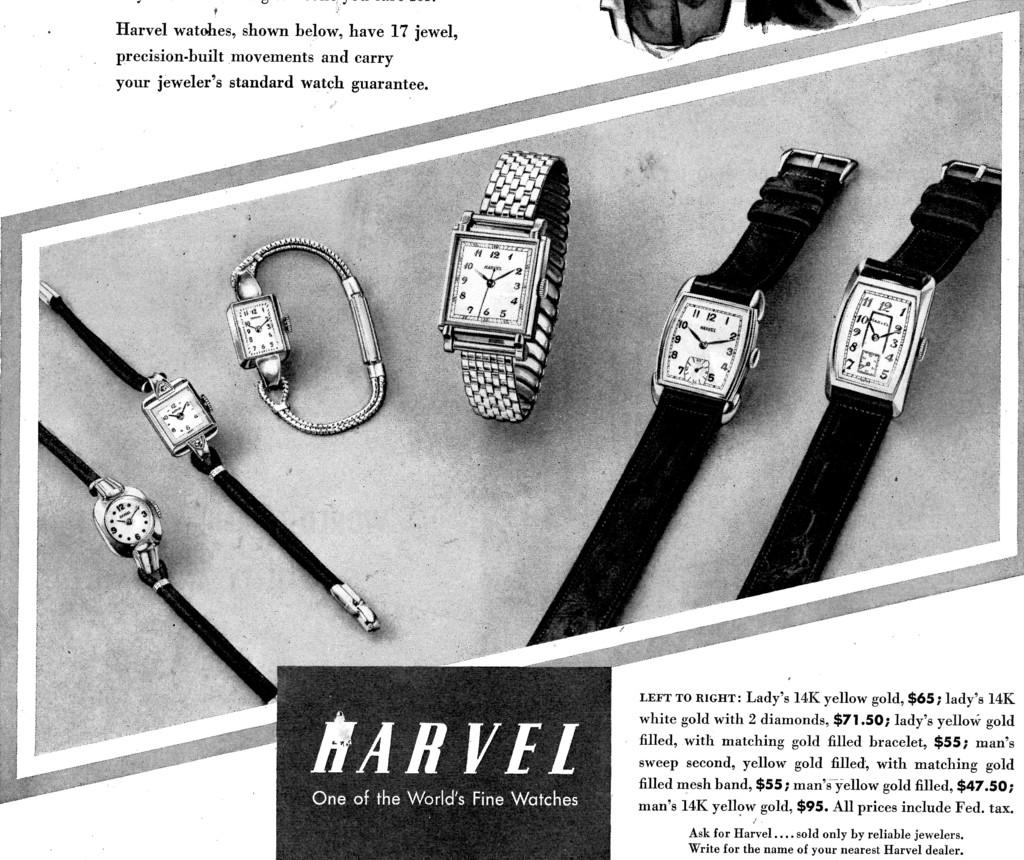<image>
Describe the image concisely. A black and white ad for Harvel watches. 